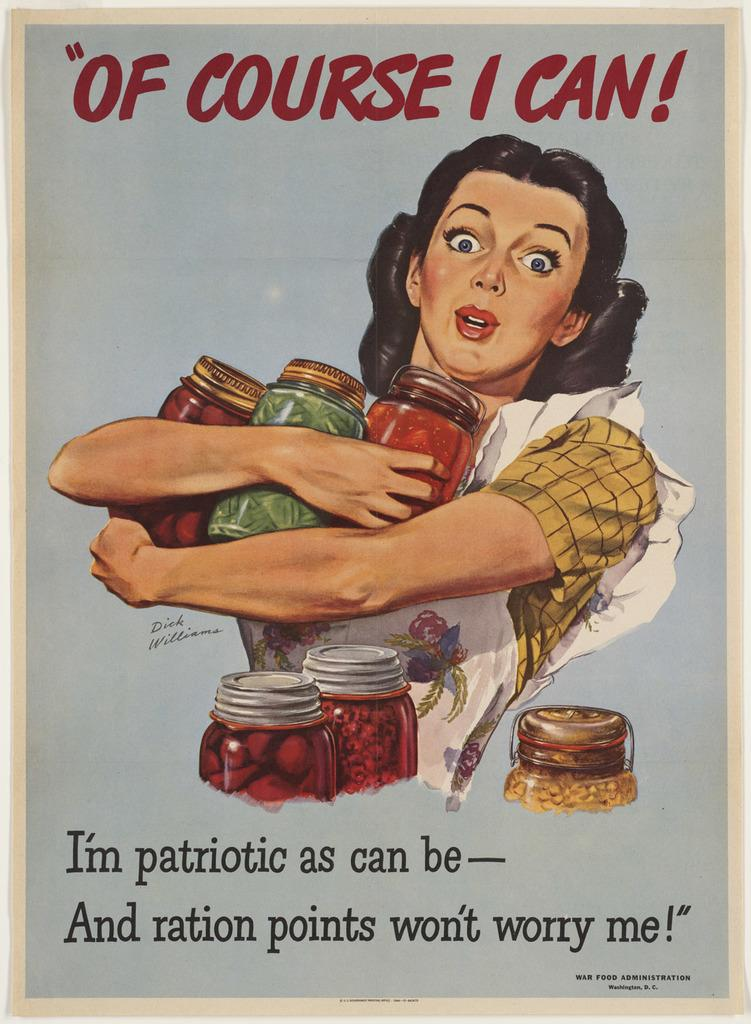<image>
Describe the image concisely. An historical poster showing a woman holding jars of food under a caption that reads "Of Course I Can!" 